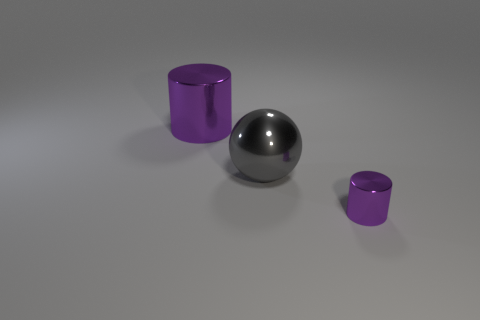Add 3 tiny gray matte things. How many objects exist? 6 Subtract all balls. How many objects are left? 2 Subtract 1 gray spheres. How many objects are left? 2 Subtract all rubber cubes. Subtract all small purple things. How many objects are left? 2 Add 3 big objects. How many big objects are left? 5 Add 1 purple rubber blocks. How many purple rubber blocks exist? 1 